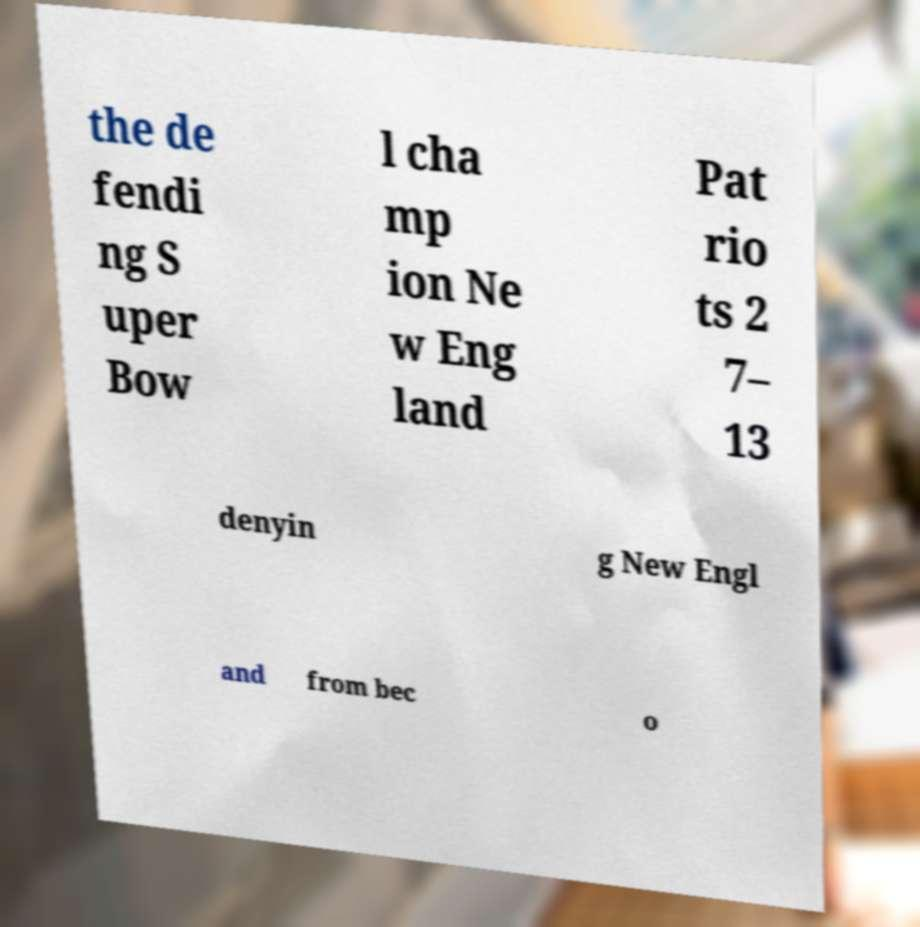Could you extract and type out the text from this image? the de fendi ng S uper Bow l cha mp ion Ne w Eng land Pat rio ts 2 7– 13 denyin g New Engl and from bec o 